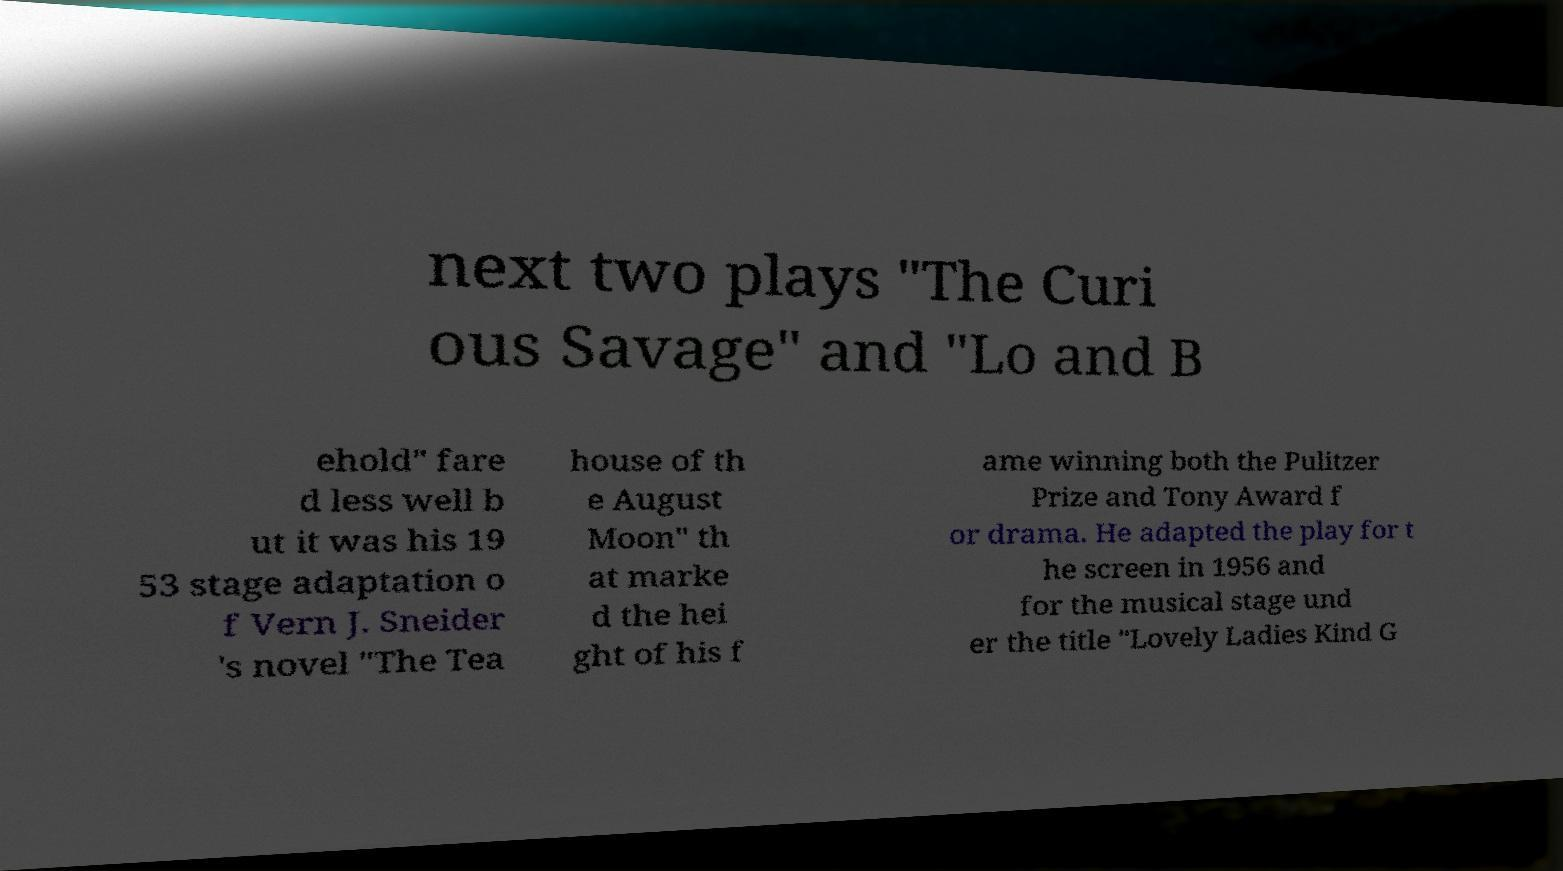For documentation purposes, I need the text within this image transcribed. Could you provide that? next two plays "The Curi ous Savage" and "Lo and B ehold" fare d less well b ut it was his 19 53 stage adaptation o f Vern J. Sneider 's novel "The Tea house of th e August Moon" th at marke d the hei ght of his f ame winning both the Pulitzer Prize and Tony Award f or drama. He adapted the play for t he screen in 1956 and for the musical stage und er the title "Lovely Ladies Kind G 